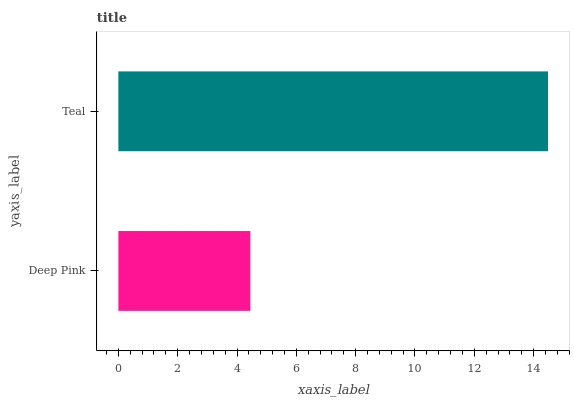Is Deep Pink the minimum?
Answer yes or no. Yes. Is Teal the maximum?
Answer yes or no. Yes. Is Teal the minimum?
Answer yes or no. No. Is Teal greater than Deep Pink?
Answer yes or no. Yes. Is Deep Pink less than Teal?
Answer yes or no. Yes. Is Deep Pink greater than Teal?
Answer yes or no. No. Is Teal less than Deep Pink?
Answer yes or no. No. Is Teal the high median?
Answer yes or no. Yes. Is Deep Pink the low median?
Answer yes or no. Yes. Is Deep Pink the high median?
Answer yes or no. No. Is Teal the low median?
Answer yes or no. No. 